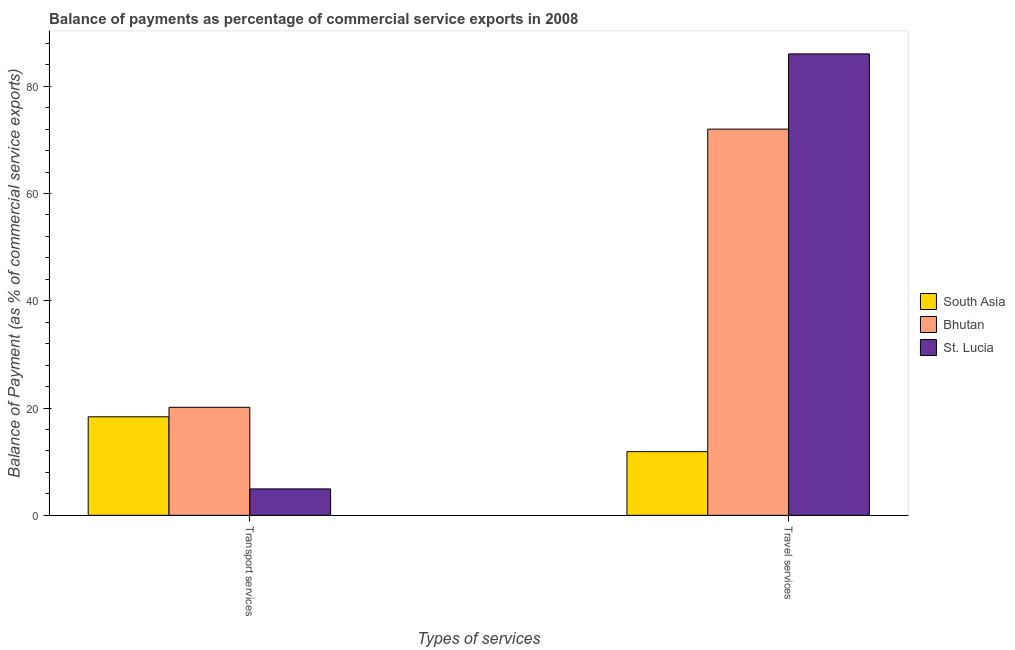How many different coloured bars are there?
Offer a very short reply. 3. How many groups of bars are there?
Your answer should be very brief. 2. How many bars are there on the 1st tick from the right?
Your answer should be very brief. 3. What is the label of the 2nd group of bars from the left?
Your answer should be very brief. Travel services. What is the balance of payments of travel services in St. Lucia?
Your response must be concise. 86.02. Across all countries, what is the maximum balance of payments of transport services?
Ensure brevity in your answer.  20.14. Across all countries, what is the minimum balance of payments of travel services?
Ensure brevity in your answer.  11.87. In which country was the balance of payments of travel services maximum?
Provide a short and direct response. St. Lucia. In which country was the balance of payments of travel services minimum?
Offer a terse response. South Asia. What is the total balance of payments of transport services in the graph?
Your answer should be very brief. 43.43. What is the difference between the balance of payments of transport services in Bhutan and that in South Asia?
Keep it short and to the point. 1.77. What is the difference between the balance of payments of travel services in St. Lucia and the balance of payments of transport services in South Asia?
Your response must be concise. 67.65. What is the average balance of payments of travel services per country?
Give a very brief answer. 56.63. What is the difference between the balance of payments of transport services and balance of payments of travel services in Bhutan?
Give a very brief answer. -51.85. What is the ratio of the balance of payments of travel services in Bhutan to that in South Asia?
Your response must be concise. 6.07. What does the 1st bar from the right in Transport services represents?
Provide a succinct answer. St. Lucia. What is the difference between two consecutive major ticks on the Y-axis?
Your answer should be very brief. 20. Are the values on the major ticks of Y-axis written in scientific E-notation?
Make the answer very short. No. Does the graph contain any zero values?
Provide a short and direct response. No. How are the legend labels stacked?
Provide a succinct answer. Vertical. What is the title of the graph?
Offer a very short reply. Balance of payments as percentage of commercial service exports in 2008. Does "Macao" appear as one of the legend labels in the graph?
Provide a short and direct response. No. What is the label or title of the X-axis?
Give a very brief answer. Types of services. What is the label or title of the Y-axis?
Offer a terse response. Balance of Payment (as % of commercial service exports). What is the Balance of Payment (as % of commercial service exports) of South Asia in Transport services?
Offer a very short reply. 18.37. What is the Balance of Payment (as % of commercial service exports) of Bhutan in Transport services?
Your response must be concise. 20.14. What is the Balance of Payment (as % of commercial service exports) in St. Lucia in Transport services?
Provide a short and direct response. 4.93. What is the Balance of Payment (as % of commercial service exports) in South Asia in Travel services?
Give a very brief answer. 11.87. What is the Balance of Payment (as % of commercial service exports) in Bhutan in Travel services?
Your answer should be very brief. 71.99. What is the Balance of Payment (as % of commercial service exports) in St. Lucia in Travel services?
Your answer should be compact. 86.02. Across all Types of services, what is the maximum Balance of Payment (as % of commercial service exports) of South Asia?
Keep it short and to the point. 18.37. Across all Types of services, what is the maximum Balance of Payment (as % of commercial service exports) in Bhutan?
Ensure brevity in your answer.  71.99. Across all Types of services, what is the maximum Balance of Payment (as % of commercial service exports) in St. Lucia?
Offer a very short reply. 86.02. Across all Types of services, what is the minimum Balance of Payment (as % of commercial service exports) in South Asia?
Your response must be concise. 11.87. Across all Types of services, what is the minimum Balance of Payment (as % of commercial service exports) in Bhutan?
Offer a terse response. 20.14. Across all Types of services, what is the minimum Balance of Payment (as % of commercial service exports) in St. Lucia?
Make the answer very short. 4.93. What is the total Balance of Payment (as % of commercial service exports) in South Asia in the graph?
Your response must be concise. 30.24. What is the total Balance of Payment (as % of commercial service exports) in Bhutan in the graph?
Make the answer very short. 92.13. What is the total Balance of Payment (as % of commercial service exports) in St. Lucia in the graph?
Give a very brief answer. 90.94. What is the difference between the Balance of Payment (as % of commercial service exports) of South Asia in Transport services and that in Travel services?
Keep it short and to the point. 6.5. What is the difference between the Balance of Payment (as % of commercial service exports) in Bhutan in Transport services and that in Travel services?
Your response must be concise. -51.85. What is the difference between the Balance of Payment (as % of commercial service exports) of St. Lucia in Transport services and that in Travel services?
Your answer should be compact. -81.09. What is the difference between the Balance of Payment (as % of commercial service exports) in South Asia in Transport services and the Balance of Payment (as % of commercial service exports) in Bhutan in Travel services?
Offer a very short reply. -53.63. What is the difference between the Balance of Payment (as % of commercial service exports) in South Asia in Transport services and the Balance of Payment (as % of commercial service exports) in St. Lucia in Travel services?
Offer a very short reply. -67.65. What is the difference between the Balance of Payment (as % of commercial service exports) in Bhutan in Transport services and the Balance of Payment (as % of commercial service exports) in St. Lucia in Travel services?
Ensure brevity in your answer.  -65.88. What is the average Balance of Payment (as % of commercial service exports) in South Asia per Types of services?
Ensure brevity in your answer.  15.12. What is the average Balance of Payment (as % of commercial service exports) of Bhutan per Types of services?
Provide a short and direct response. 46.07. What is the average Balance of Payment (as % of commercial service exports) in St. Lucia per Types of services?
Ensure brevity in your answer.  45.47. What is the difference between the Balance of Payment (as % of commercial service exports) in South Asia and Balance of Payment (as % of commercial service exports) in Bhutan in Transport services?
Keep it short and to the point. -1.77. What is the difference between the Balance of Payment (as % of commercial service exports) in South Asia and Balance of Payment (as % of commercial service exports) in St. Lucia in Transport services?
Give a very brief answer. 13.44. What is the difference between the Balance of Payment (as % of commercial service exports) in Bhutan and Balance of Payment (as % of commercial service exports) in St. Lucia in Transport services?
Make the answer very short. 15.21. What is the difference between the Balance of Payment (as % of commercial service exports) of South Asia and Balance of Payment (as % of commercial service exports) of Bhutan in Travel services?
Give a very brief answer. -60.12. What is the difference between the Balance of Payment (as % of commercial service exports) in South Asia and Balance of Payment (as % of commercial service exports) in St. Lucia in Travel services?
Offer a terse response. -74.15. What is the difference between the Balance of Payment (as % of commercial service exports) of Bhutan and Balance of Payment (as % of commercial service exports) of St. Lucia in Travel services?
Make the answer very short. -14.02. What is the ratio of the Balance of Payment (as % of commercial service exports) in South Asia in Transport services to that in Travel services?
Your answer should be very brief. 1.55. What is the ratio of the Balance of Payment (as % of commercial service exports) in Bhutan in Transport services to that in Travel services?
Keep it short and to the point. 0.28. What is the ratio of the Balance of Payment (as % of commercial service exports) of St. Lucia in Transport services to that in Travel services?
Your response must be concise. 0.06. What is the difference between the highest and the second highest Balance of Payment (as % of commercial service exports) in South Asia?
Your answer should be very brief. 6.5. What is the difference between the highest and the second highest Balance of Payment (as % of commercial service exports) of Bhutan?
Ensure brevity in your answer.  51.85. What is the difference between the highest and the second highest Balance of Payment (as % of commercial service exports) of St. Lucia?
Ensure brevity in your answer.  81.09. What is the difference between the highest and the lowest Balance of Payment (as % of commercial service exports) of South Asia?
Provide a short and direct response. 6.5. What is the difference between the highest and the lowest Balance of Payment (as % of commercial service exports) of Bhutan?
Provide a succinct answer. 51.85. What is the difference between the highest and the lowest Balance of Payment (as % of commercial service exports) in St. Lucia?
Provide a succinct answer. 81.09. 